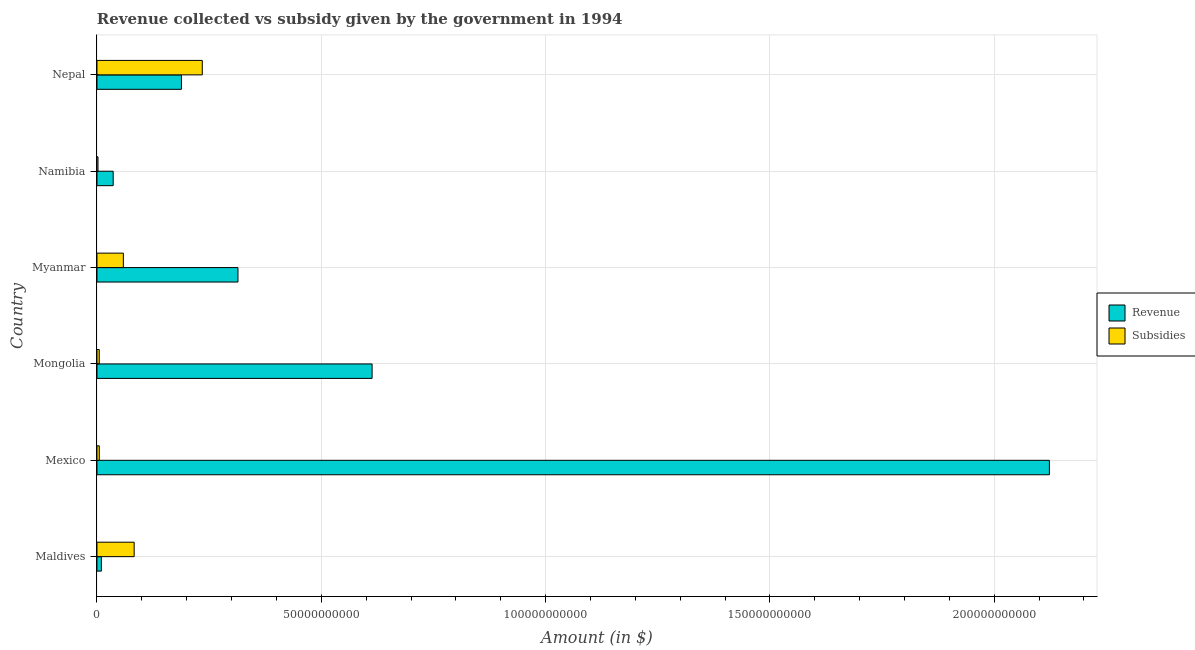How many different coloured bars are there?
Provide a short and direct response. 2. How many bars are there on the 6th tick from the top?
Keep it short and to the point. 2. What is the label of the 2nd group of bars from the top?
Give a very brief answer. Namibia. In how many cases, is the number of bars for a given country not equal to the number of legend labels?
Offer a very short reply. 0. What is the amount of revenue collected in Mongolia?
Offer a terse response. 6.13e+1. Across all countries, what is the maximum amount of revenue collected?
Provide a short and direct response. 2.12e+11. Across all countries, what is the minimum amount of revenue collected?
Provide a succinct answer. 9.80e+08. In which country was the amount of revenue collected maximum?
Ensure brevity in your answer.  Mexico. In which country was the amount of revenue collected minimum?
Your response must be concise. Maldives. What is the total amount of subsidies given in the graph?
Ensure brevity in your answer.  3.89e+1. What is the difference between the amount of revenue collected in Namibia and that in Nepal?
Offer a very short reply. -1.52e+1. What is the difference between the amount of revenue collected in Mexico and the amount of subsidies given in Nepal?
Provide a succinct answer. 1.89e+11. What is the average amount of subsidies given per country?
Ensure brevity in your answer.  6.48e+09. What is the difference between the amount of subsidies given and amount of revenue collected in Mongolia?
Provide a succinct answer. -6.08e+1. In how many countries, is the amount of subsidies given greater than 150000000000 $?
Your answer should be very brief. 0. What is the ratio of the amount of revenue collected in Mexico to that in Nepal?
Make the answer very short. 11.28. Is the amount of revenue collected in Mongolia less than that in Namibia?
Your answer should be compact. No. What is the difference between the highest and the second highest amount of revenue collected?
Give a very brief answer. 1.51e+11. What is the difference between the highest and the lowest amount of subsidies given?
Your response must be concise. 2.32e+1. What does the 1st bar from the top in Myanmar represents?
Provide a succinct answer. Subsidies. What does the 2nd bar from the bottom in Nepal represents?
Provide a succinct answer. Subsidies. How many bars are there?
Make the answer very short. 12. Are all the bars in the graph horizontal?
Your response must be concise. Yes. How many countries are there in the graph?
Ensure brevity in your answer.  6. What is the difference between two consecutive major ticks on the X-axis?
Provide a succinct answer. 5.00e+1. How are the legend labels stacked?
Make the answer very short. Vertical. What is the title of the graph?
Offer a terse response. Revenue collected vs subsidy given by the government in 1994. What is the label or title of the X-axis?
Offer a very short reply. Amount (in $). What is the Amount (in $) of Revenue in Maldives?
Offer a terse response. 9.80e+08. What is the Amount (in $) in Subsidies in Maldives?
Offer a very short reply. 8.29e+09. What is the Amount (in $) in Revenue in Mexico?
Provide a succinct answer. 2.12e+11. What is the Amount (in $) in Subsidies in Mexico?
Ensure brevity in your answer.  5.15e+08. What is the Amount (in $) of Revenue in Mongolia?
Give a very brief answer. 6.13e+1. What is the Amount (in $) of Subsidies in Mongolia?
Provide a succinct answer. 5.07e+08. What is the Amount (in $) in Revenue in Myanmar?
Offer a very short reply. 3.14e+1. What is the Amount (in $) of Subsidies in Myanmar?
Make the answer very short. 5.88e+09. What is the Amount (in $) of Revenue in Namibia?
Give a very brief answer. 3.61e+09. What is the Amount (in $) of Subsidies in Namibia?
Your response must be concise. 2.28e+08. What is the Amount (in $) in Revenue in Nepal?
Offer a very short reply. 1.88e+1. What is the Amount (in $) of Subsidies in Nepal?
Offer a terse response. 2.35e+1. Across all countries, what is the maximum Amount (in $) of Revenue?
Offer a terse response. 2.12e+11. Across all countries, what is the maximum Amount (in $) of Subsidies?
Your answer should be compact. 2.35e+1. Across all countries, what is the minimum Amount (in $) in Revenue?
Your answer should be compact. 9.80e+08. Across all countries, what is the minimum Amount (in $) of Subsidies?
Ensure brevity in your answer.  2.28e+08. What is the total Amount (in $) in Revenue in the graph?
Keep it short and to the point. 3.28e+11. What is the total Amount (in $) in Subsidies in the graph?
Your answer should be very brief. 3.89e+1. What is the difference between the Amount (in $) in Revenue in Maldives and that in Mexico?
Keep it short and to the point. -2.11e+11. What is the difference between the Amount (in $) in Subsidies in Maldives and that in Mexico?
Offer a terse response. 7.77e+09. What is the difference between the Amount (in $) in Revenue in Maldives and that in Mongolia?
Your answer should be very brief. -6.03e+1. What is the difference between the Amount (in $) of Subsidies in Maldives and that in Mongolia?
Keep it short and to the point. 7.78e+09. What is the difference between the Amount (in $) in Revenue in Maldives and that in Myanmar?
Your answer should be compact. -3.05e+1. What is the difference between the Amount (in $) of Subsidies in Maldives and that in Myanmar?
Make the answer very short. 2.41e+09. What is the difference between the Amount (in $) of Revenue in Maldives and that in Namibia?
Your answer should be very brief. -2.63e+09. What is the difference between the Amount (in $) of Subsidies in Maldives and that in Namibia?
Your answer should be compact. 8.06e+09. What is the difference between the Amount (in $) of Revenue in Maldives and that in Nepal?
Provide a short and direct response. -1.78e+1. What is the difference between the Amount (in $) in Subsidies in Maldives and that in Nepal?
Offer a terse response. -1.52e+1. What is the difference between the Amount (in $) in Revenue in Mexico and that in Mongolia?
Make the answer very short. 1.51e+11. What is the difference between the Amount (in $) of Subsidies in Mexico and that in Mongolia?
Offer a very short reply. 8.88e+06. What is the difference between the Amount (in $) in Revenue in Mexico and that in Myanmar?
Offer a very short reply. 1.81e+11. What is the difference between the Amount (in $) in Subsidies in Mexico and that in Myanmar?
Your response must be concise. -5.37e+09. What is the difference between the Amount (in $) of Revenue in Mexico and that in Namibia?
Ensure brevity in your answer.  2.09e+11. What is the difference between the Amount (in $) in Subsidies in Mexico and that in Namibia?
Offer a very short reply. 2.88e+08. What is the difference between the Amount (in $) of Revenue in Mexico and that in Nepal?
Provide a succinct answer. 1.93e+11. What is the difference between the Amount (in $) in Subsidies in Mexico and that in Nepal?
Your response must be concise. -2.30e+1. What is the difference between the Amount (in $) of Revenue in Mongolia and that in Myanmar?
Provide a short and direct response. 2.99e+1. What is the difference between the Amount (in $) of Subsidies in Mongolia and that in Myanmar?
Ensure brevity in your answer.  -5.38e+09. What is the difference between the Amount (in $) in Revenue in Mongolia and that in Namibia?
Provide a short and direct response. 5.77e+1. What is the difference between the Amount (in $) in Subsidies in Mongolia and that in Namibia?
Make the answer very short. 2.79e+08. What is the difference between the Amount (in $) of Revenue in Mongolia and that in Nepal?
Provide a succinct answer. 4.25e+1. What is the difference between the Amount (in $) in Subsidies in Mongolia and that in Nepal?
Provide a succinct answer. -2.30e+1. What is the difference between the Amount (in $) of Revenue in Myanmar and that in Namibia?
Your response must be concise. 2.78e+1. What is the difference between the Amount (in $) of Subsidies in Myanmar and that in Namibia?
Your answer should be compact. 5.66e+09. What is the difference between the Amount (in $) in Revenue in Myanmar and that in Nepal?
Make the answer very short. 1.26e+1. What is the difference between the Amount (in $) in Subsidies in Myanmar and that in Nepal?
Make the answer very short. -1.76e+1. What is the difference between the Amount (in $) of Revenue in Namibia and that in Nepal?
Provide a short and direct response. -1.52e+1. What is the difference between the Amount (in $) in Subsidies in Namibia and that in Nepal?
Offer a very short reply. -2.32e+1. What is the difference between the Amount (in $) in Revenue in Maldives and the Amount (in $) in Subsidies in Mexico?
Ensure brevity in your answer.  4.64e+08. What is the difference between the Amount (in $) of Revenue in Maldives and the Amount (in $) of Subsidies in Mongolia?
Provide a succinct answer. 4.73e+08. What is the difference between the Amount (in $) in Revenue in Maldives and the Amount (in $) in Subsidies in Myanmar?
Provide a short and direct response. -4.90e+09. What is the difference between the Amount (in $) of Revenue in Maldives and the Amount (in $) of Subsidies in Namibia?
Provide a short and direct response. 7.52e+08. What is the difference between the Amount (in $) in Revenue in Maldives and the Amount (in $) in Subsidies in Nepal?
Offer a very short reply. -2.25e+1. What is the difference between the Amount (in $) in Revenue in Mexico and the Amount (in $) in Subsidies in Mongolia?
Offer a terse response. 2.12e+11. What is the difference between the Amount (in $) in Revenue in Mexico and the Amount (in $) in Subsidies in Myanmar?
Your answer should be very brief. 2.06e+11. What is the difference between the Amount (in $) of Revenue in Mexico and the Amount (in $) of Subsidies in Namibia?
Offer a terse response. 2.12e+11. What is the difference between the Amount (in $) in Revenue in Mexico and the Amount (in $) in Subsidies in Nepal?
Your answer should be very brief. 1.89e+11. What is the difference between the Amount (in $) in Revenue in Mongolia and the Amount (in $) in Subsidies in Myanmar?
Keep it short and to the point. 5.54e+1. What is the difference between the Amount (in $) of Revenue in Mongolia and the Amount (in $) of Subsidies in Namibia?
Provide a short and direct response. 6.11e+1. What is the difference between the Amount (in $) of Revenue in Mongolia and the Amount (in $) of Subsidies in Nepal?
Provide a succinct answer. 3.79e+1. What is the difference between the Amount (in $) in Revenue in Myanmar and the Amount (in $) in Subsidies in Namibia?
Offer a very short reply. 3.12e+1. What is the difference between the Amount (in $) in Revenue in Myanmar and the Amount (in $) in Subsidies in Nepal?
Make the answer very short. 7.96e+09. What is the difference between the Amount (in $) in Revenue in Namibia and the Amount (in $) in Subsidies in Nepal?
Ensure brevity in your answer.  -1.99e+1. What is the average Amount (in $) in Revenue per country?
Your answer should be compact. 5.47e+1. What is the average Amount (in $) of Subsidies per country?
Your answer should be compact. 6.48e+09. What is the difference between the Amount (in $) in Revenue and Amount (in $) in Subsidies in Maldives?
Offer a terse response. -7.31e+09. What is the difference between the Amount (in $) of Revenue and Amount (in $) of Subsidies in Mexico?
Make the answer very short. 2.12e+11. What is the difference between the Amount (in $) in Revenue and Amount (in $) in Subsidies in Mongolia?
Offer a very short reply. 6.08e+1. What is the difference between the Amount (in $) of Revenue and Amount (in $) of Subsidies in Myanmar?
Your answer should be very brief. 2.55e+1. What is the difference between the Amount (in $) of Revenue and Amount (in $) of Subsidies in Namibia?
Offer a terse response. 3.38e+09. What is the difference between the Amount (in $) of Revenue and Amount (in $) of Subsidies in Nepal?
Offer a terse response. -4.65e+09. What is the ratio of the Amount (in $) of Revenue in Maldives to that in Mexico?
Offer a terse response. 0. What is the ratio of the Amount (in $) in Subsidies in Maldives to that in Mexico?
Provide a short and direct response. 16.08. What is the ratio of the Amount (in $) of Revenue in Maldives to that in Mongolia?
Provide a short and direct response. 0.02. What is the ratio of the Amount (in $) in Subsidies in Maldives to that in Mongolia?
Provide a short and direct response. 16.37. What is the ratio of the Amount (in $) in Revenue in Maldives to that in Myanmar?
Your response must be concise. 0.03. What is the ratio of the Amount (in $) of Subsidies in Maldives to that in Myanmar?
Your response must be concise. 1.41. What is the ratio of the Amount (in $) in Revenue in Maldives to that in Namibia?
Your answer should be compact. 0.27. What is the ratio of the Amount (in $) in Subsidies in Maldives to that in Namibia?
Ensure brevity in your answer.  36.44. What is the ratio of the Amount (in $) in Revenue in Maldives to that in Nepal?
Keep it short and to the point. 0.05. What is the ratio of the Amount (in $) of Subsidies in Maldives to that in Nepal?
Keep it short and to the point. 0.35. What is the ratio of the Amount (in $) in Revenue in Mexico to that in Mongolia?
Provide a succinct answer. 3.46. What is the ratio of the Amount (in $) of Subsidies in Mexico to that in Mongolia?
Your response must be concise. 1.02. What is the ratio of the Amount (in $) of Revenue in Mexico to that in Myanmar?
Give a very brief answer. 6.75. What is the ratio of the Amount (in $) of Subsidies in Mexico to that in Myanmar?
Provide a succinct answer. 0.09. What is the ratio of the Amount (in $) in Revenue in Mexico to that in Namibia?
Your response must be concise. 58.8. What is the ratio of the Amount (in $) of Subsidies in Mexico to that in Namibia?
Make the answer very short. 2.27. What is the ratio of the Amount (in $) in Revenue in Mexico to that in Nepal?
Give a very brief answer. 11.28. What is the ratio of the Amount (in $) in Subsidies in Mexico to that in Nepal?
Your answer should be compact. 0.02. What is the ratio of the Amount (in $) of Revenue in Mongolia to that in Myanmar?
Your answer should be very brief. 1.95. What is the ratio of the Amount (in $) in Subsidies in Mongolia to that in Myanmar?
Your answer should be compact. 0.09. What is the ratio of the Amount (in $) of Revenue in Mongolia to that in Namibia?
Your response must be concise. 16.98. What is the ratio of the Amount (in $) of Subsidies in Mongolia to that in Namibia?
Offer a very short reply. 2.23. What is the ratio of the Amount (in $) of Revenue in Mongolia to that in Nepal?
Give a very brief answer. 3.26. What is the ratio of the Amount (in $) in Subsidies in Mongolia to that in Nepal?
Your response must be concise. 0.02. What is the ratio of the Amount (in $) in Revenue in Myanmar to that in Namibia?
Make the answer very short. 8.7. What is the ratio of the Amount (in $) in Subsidies in Myanmar to that in Namibia?
Keep it short and to the point. 25.86. What is the ratio of the Amount (in $) of Revenue in Myanmar to that in Nepal?
Provide a short and direct response. 1.67. What is the ratio of the Amount (in $) in Subsidies in Myanmar to that in Nepal?
Your answer should be compact. 0.25. What is the ratio of the Amount (in $) of Revenue in Namibia to that in Nepal?
Make the answer very short. 0.19. What is the ratio of the Amount (in $) of Subsidies in Namibia to that in Nepal?
Your answer should be very brief. 0.01. What is the difference between the highest and the second highest Amount (in $) of Revenue?
Provide a short and direct response. 1.51e+11. What is the difference between the highest and the second highest Amount (in $) in Subsidies?
Give a very brief answer. 1.52e+1. What is the difference between the highest and the lowest Amount (in $) of Revenue?
Your answer should be compact. 2.11e+11. What is the difference between the highest and the lowest Amount (in $) of Subsidies?
Make the answer very short. 2.32e+1. 